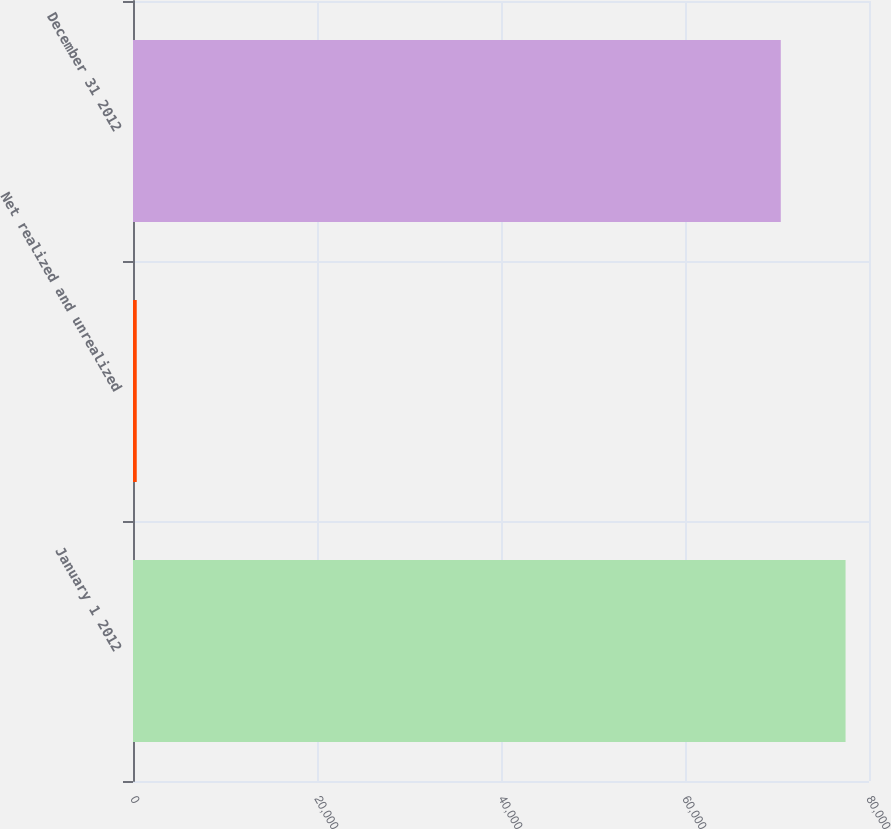<chart> <loc_0><loc_0><loc_500><loc_500><bar_chart><fcel>January 1 2012<fcel>Net realized and unrealized<fcel>December 31 2012<nl><fcel>77452.1<fcel>407<fcel>70411<nl></chart> 